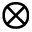<formula> <loc_0><loc_0><loc_500><loc_500>\otimes</formula> 